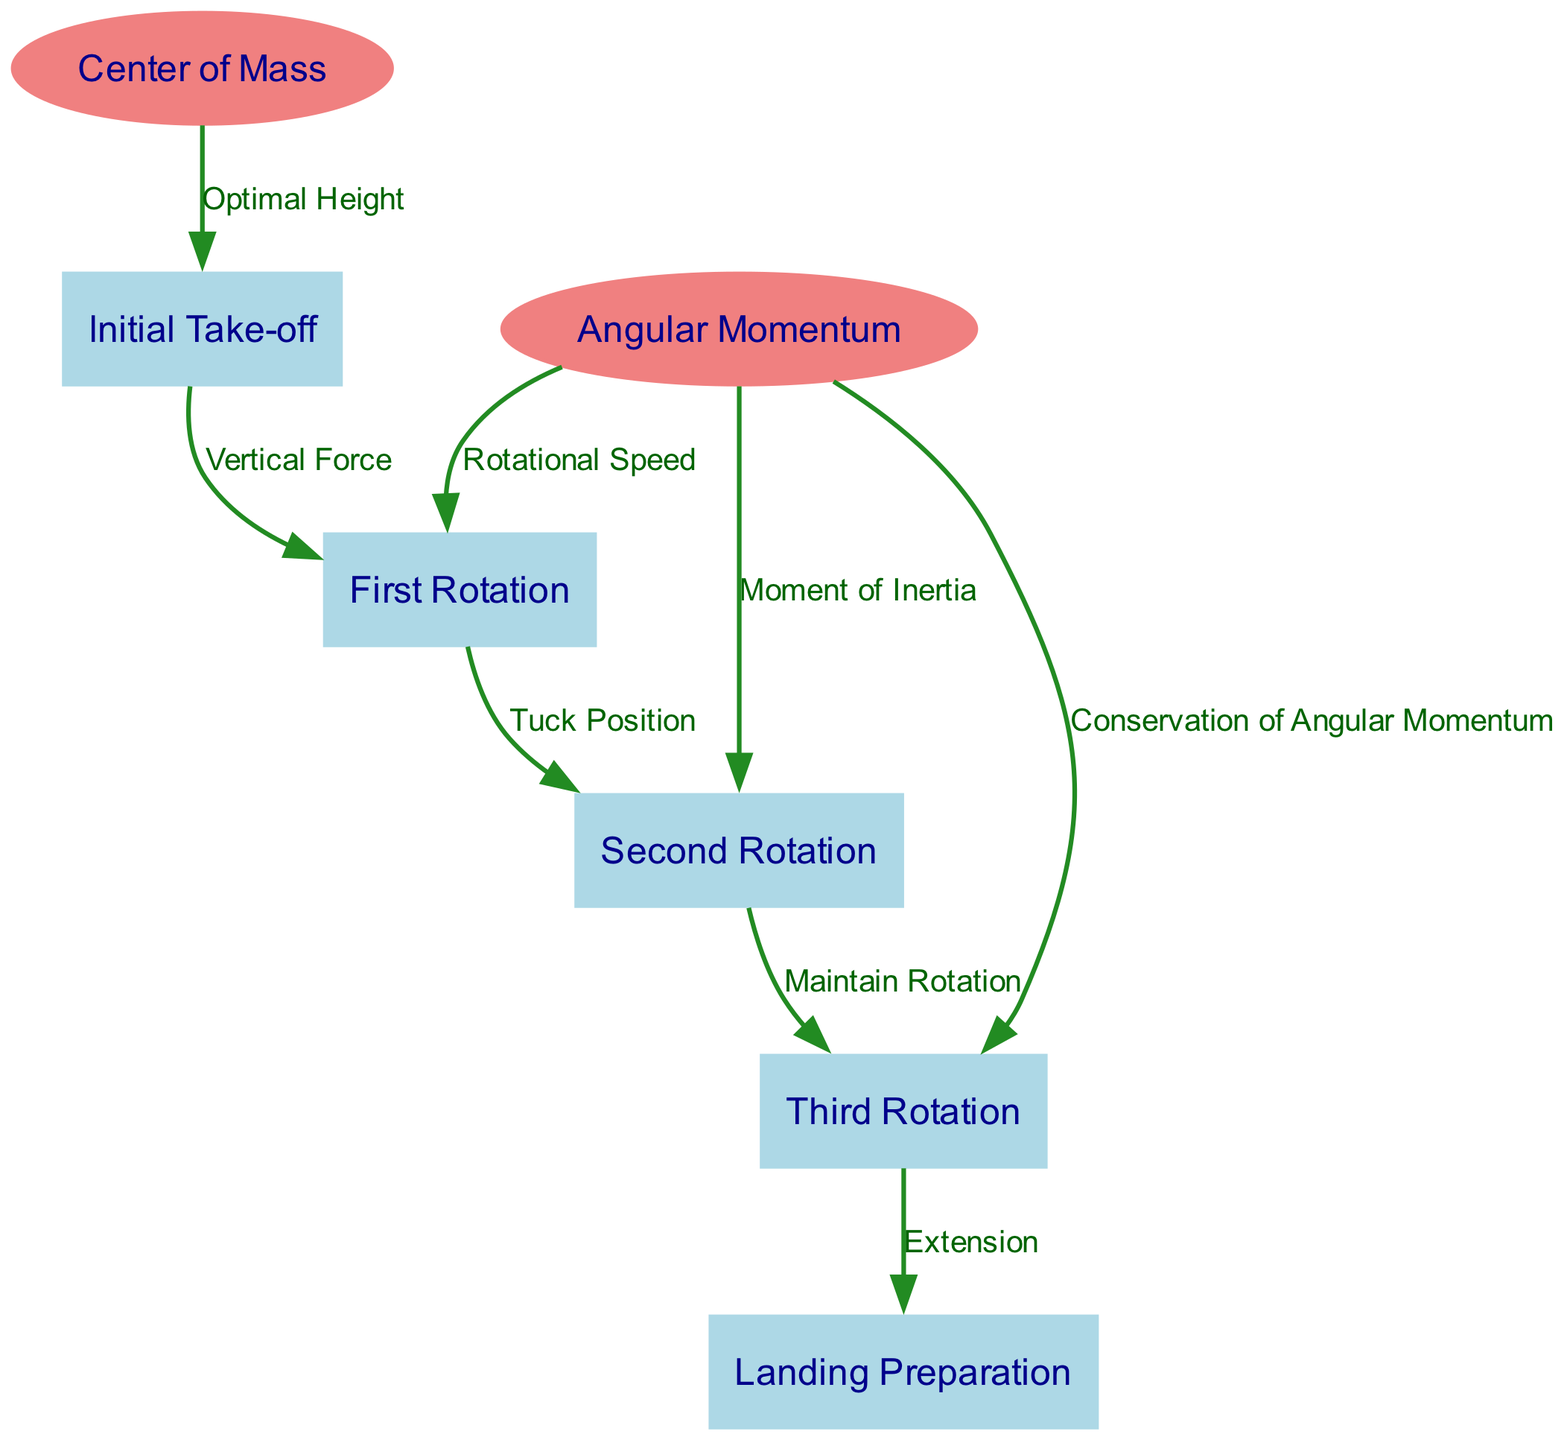What is the initial stage of the triple backflip? The diagram identifies the "Initial Take-off" as the first node, which represents the beginning of the gymnast's maneuver.
Answer: Initial Take-off What force acts between the "Initial Take-off" and "First Rotation"? The edge connecting these two nodes is labeled "Vertical Force," indicating that this force is applied during the take-off phase leading into the first rotation.
Answer: Vertical Force How many rotations does the gymnast perform? The nodes labeled "First Rotation," "Second Rotation," and "Third Rotation" indicate a total of three rotations in the diagram.
Answer: Three What helps maintain the gymnast's rotation during the second phase? The edge labeled "Tuck Position" connects "First Rotation" to "Second Rotation," implying that the tuck position helps to maintain the gymnast's rotation in this phase.
Answer: Tuck Position What is conserved throughout the three rotations? The edge labeled "Conservation of Angular Momentum," which connects the "Angular Momentum" node to the "Third Rotation" node, indicates that angular momentum is conserved during the rotations.
Answer: Angular Momentum Which phase of the maneuver prepares for landing? The diagram shows the transition from "Third Rotation" to "Landing Preparation," clearly labeling the latter as the preparation phase for landing.
Answer: Landing Preparation What is the role of the "Center of Mass" in relation to the "Initial Take-off"? The edge labeled "Optimal Height" indicates that the center of mass is considered to be at an optimal height for launching into the initial take-off phase of the maneuver.
Answer: Optimal Height How does "Rotational Speed" affect the transition from "First Rotation" to "Second Rotation"? The edge labeled "Rotational Speed" connects the "Angular Momentum" node to the "First Rotation," suggesting that this speed is crucial for initiating the second rotation.
Answer: Rotational Speed What is a key factor that influences the gymnast's "Second Rotation"? The edge labeled "Moment of Inertia" connects "Angular Momentum" to "Second Rotation," indicating that the moment of inertia is an important factor influencing this phase.
Answer: Moment of Inertia 